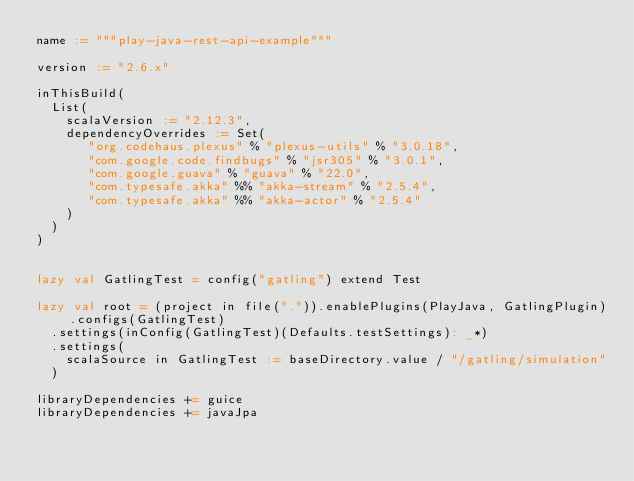<code> <loc_0><loc_0><loc_500><loc_500><_Scala_>name := """play-java-rest-api-example"""

version := "2.6.x"

inThisBuild(
  List(
    scalaVersion := "2.12.3",
    dependencyOverrides := Set(
       "org.codehaus.plexus" % "plexus-utils" % "3.0.18",
       "com.google.code.findbugs" % "jsr305" % "3.0.1",
       "com.google.guava" % "guava" % "22.0",
       "com.typesafe.akka" %% "akka-stream" % "2.5.4",
       "com.typesafe.akka" %% "akka-actor" % "2.5.4"
    )
  )
)


lazy val GatlingTest = config("gatling") extend Test

lazy val root = (project in file(".")).enablePlugins(PlayJava, GatlingPlugin).configs(GatlingTest)
  .settings(inConfig(GatlingTest)(Defaults.testSettings): _*)
  .settings(
    scalaSource in GatlingTest := baseDirectory.value / "/gatling/simulation"
  )

libraryDependencies += guice
libraryDependencies += javaJpa</code> 